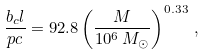<formula> <loc_0><loc_0><loc_500><loc_500>\frac { b _ { c } l } { p c } = 9 2 . 8 \left ( \frac { M } { 1 0 ^ { 6 } \, M _ { \odot } } \right ) ^ { 0 . 3 3 } \, ,</formula> 